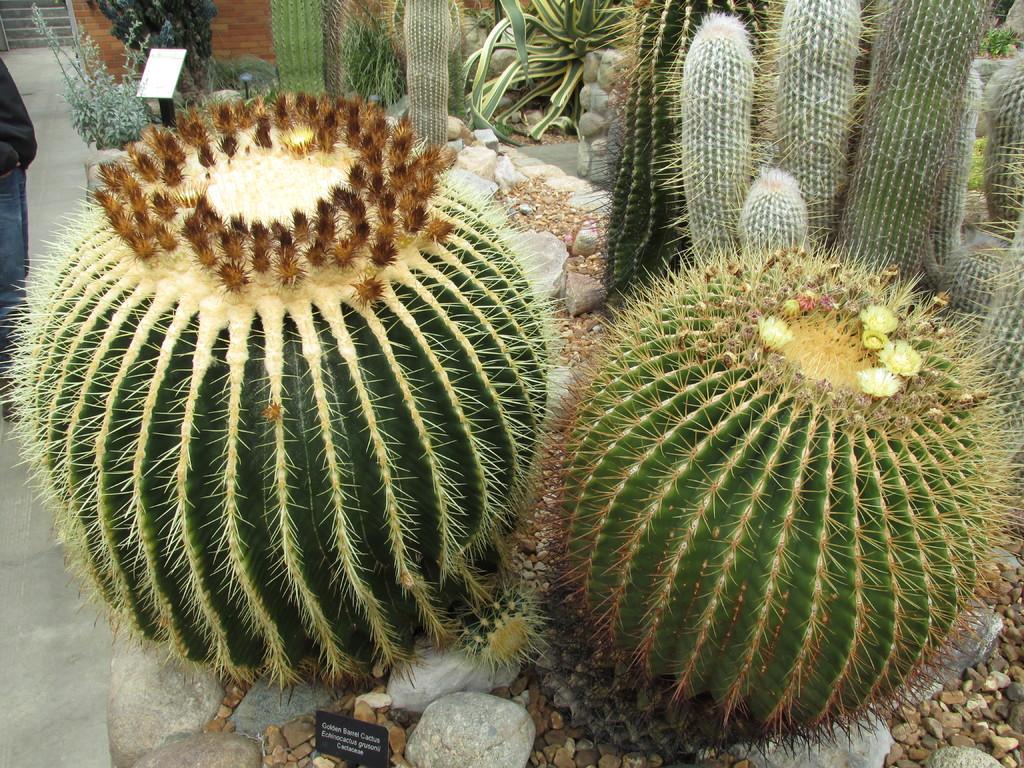Could you give a brief overview of what you see in this image? In this image we can see there are some cactus plants, stones and one person is standing on the road, in the background there are stairs. 